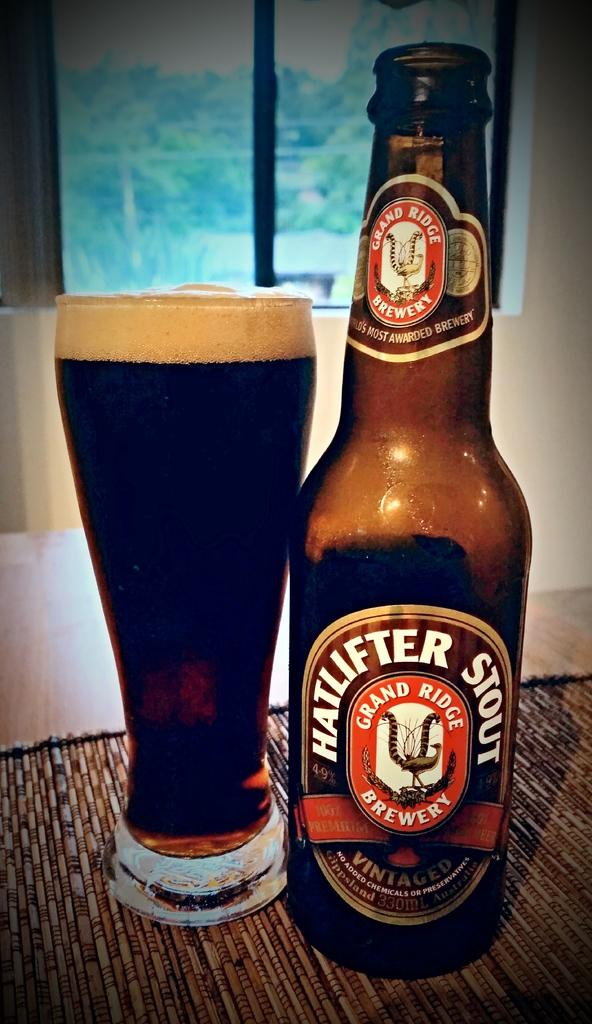<image>
Share a concise interpretation of the image provided. A bottle of Hatlifter Stout next to a full glass on a table. 